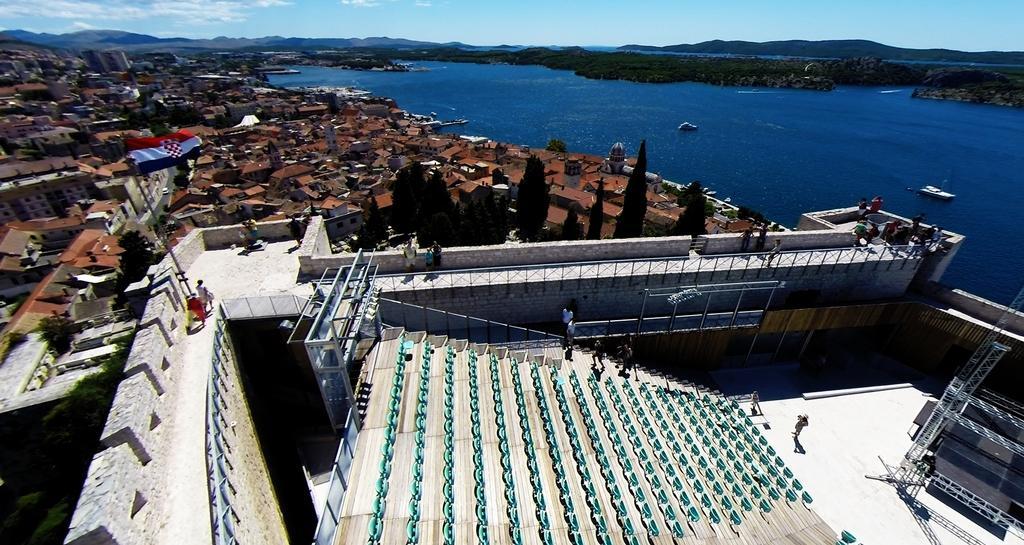Please provide a concise description of this image. At the bottom of the image we can see a stadium, in the stadium we can see some chairs and few people are standing and walking. Behind the stadium we can see some trees, poles and buildings. In the middle of the image we can see water, above the water we can see some ships. Background of the image we can see some hills. At the top of the image we can see some clouds in the sky. 